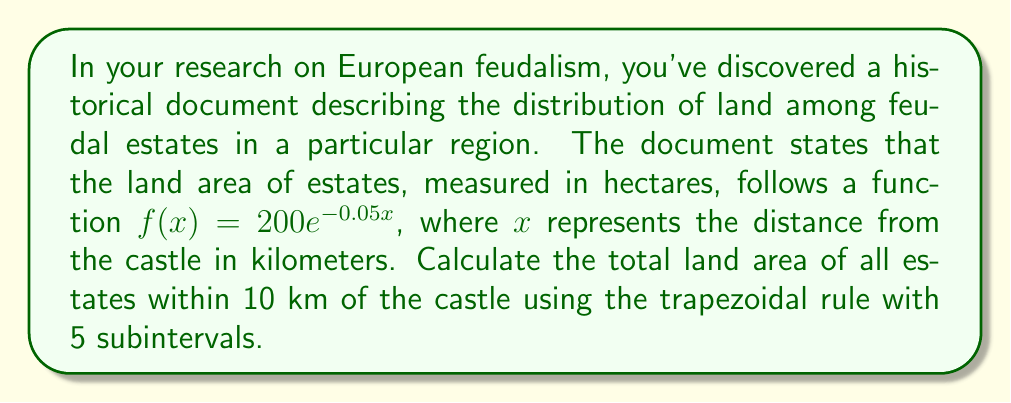What is the answer to this math problem? To solve this problem, we'll use the trapezoidal rule for numerical integration. The steps are as follows:

1) The trapezoidal rule for n subintervals is given by:

   $$\int_{a}^{b} f(x) dx \approx \frac{h}{2}[f(x_0) + 2f(x_1) + 2f(x_2) + ... + 2f(x_{n-1}) + f(x_n)]$$

   where $h = \frac{b-a}{n}$, and $x_i = a + ih$ for $i = 0, 1, ..., n$

2) In our case, $a = 0$, $b = 10$, and $n = 5$. So, $h = \frac{10-0}{5} = 2$

3) We need to calculate $f(x)$ for $x = 0, 2, 4, 6, 8, 10$:

   $f(0) = 200e^{-0.05(0)} = 200$
   $f(2) = 200e^{-0.05(2)} \approx 181.27$
   $f(4) = 200e^{-0.05(4)} \approx 164.45$
   $f(6) = 200e^{-0.05(6)} \approx 149.18$
   $f(8) = 200e^{-0.05(8)} \approx 135.34$
   $f(10) = 200e^{-0.05(10)} \approx 122.76$

4) Applying the trapezoidal rule:

   $$\text{Area} \approx \frac{2}{2}[200 + 2(181.27) + 2(164.45) + 2(149.18) + 2(135.34) + 122.76]$$

5) Simplifying:

   $$\text{Area} \approx 1(200 + 362.54 + 328.90 + 298.36 + 270.68 + 122.76)$$
   $$\text{Area} \approx 1583.24$$

Therefore, the total land area of all estates within 10 km of the castle is approximately 1583.24 hectares.
Answer: 1583.24 hectares 